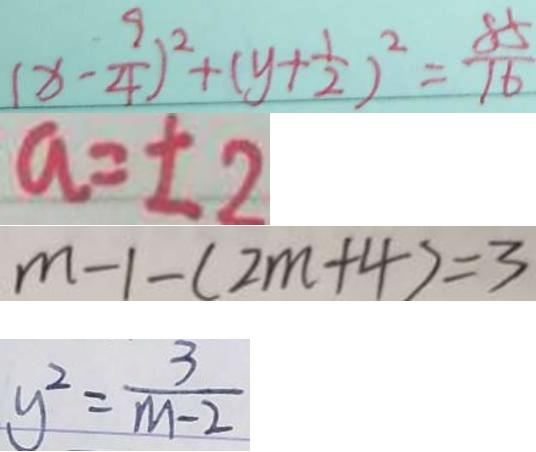<formula> <loc_0><loc_0><loc_500><loc_500>( x - \frac { 9 } { 4 } ) ^ { 2 } + ( y + \frac { 1 } { 2 } ) ^ { 2 } = \frac { 8 5 } { 1 6 } 
 a = \pm 2 
 m - 1 - ( 2 m + 4 ) = 3 
 y ^ { 2 } = \frac { 3 } { m - 2 }</formula> 